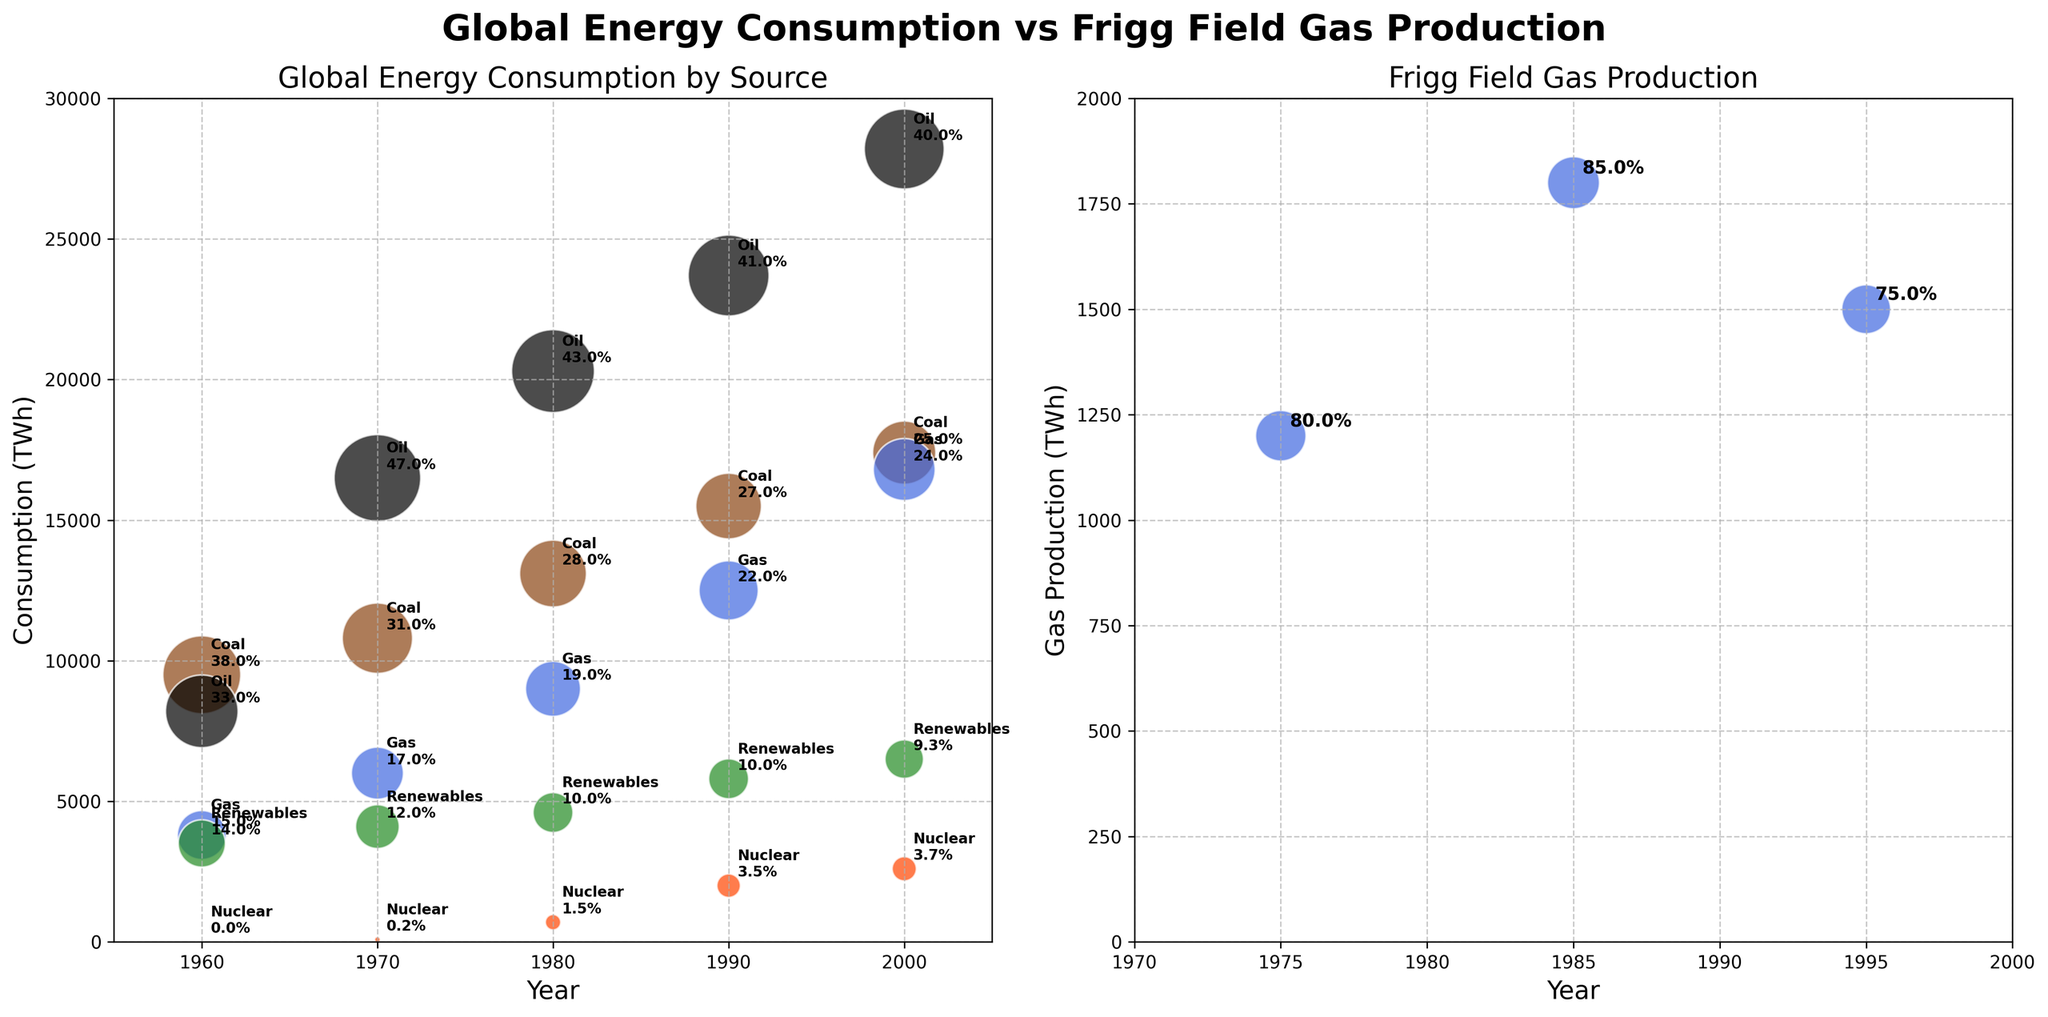What are the two plots in the figure titled? The titles of the two plots are "Global Energy Consumption by Source" and "Frigg Field Gas Production".
Answer: Global Energy Consumption by Source and Frigg Field Gas Production What is the range of years shown in the Frigg Field Gas Production plot? The Frigg Field Gas Production plot shows a range of years from 1970 to 2000.
Answer: 1970 to 2000 Which energy source had the highest share of global consumption in 1970? In the Global Energy Consumption plot, the oil source had the highest share in 1970, annotated with 47%.
Answer: Oil How did the global share of coal consumption change from 1960 to 2000? In 1960, coal had a global share of 38%. By 2000, its share had decreased to 25%.
Answer: Decreased from 38% to 25% Compare the Gas consumption share in 1960 and 2000 for the Global plot. How much did it increase or decrease? In the Global plot, Gas consumption share increased from 15% in 1960 to 24% in 2000. The increase is 24% - 15% = 9%.
Answer: Increased by 9% What is the consumption of nuclear energy in 1980? In the Global plot, the nuclear energy consumption in 1980 is annotated as 700 TWh.
Answer: 700 TWh What is the approximate size of the bubbles used to represent the share percentages in the Global plot? In the Global plot, the bubbles are sized based on share percentages, roughly correlating to 50 times the share percentage values.
Answer: approximately 50 times the share percentage values Which year shows the highest gas production in the Frigg Field Gas Production plot? 1985 shows the highest gas production in the Frigg Field Gas Production plot, with 1800 TWh.
Answer: 1985 How does oil consumption in 1980 compare to 1970 in the Global plot? In the Global plot, oil consumption increases from 16500 TWh in 1970 to 20300 TWh in 1980.
Answer: Increased by 3800 TWh What trend is observed in the share of renewable energy from 1960 to 2000 in the Global plot? Renewable energy share in the Global plot slightly decreases from 14% in 1960 to 9.3% in 2000.
Answer: Decreases from 14% to 9.3% 